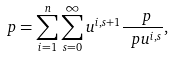<formula> <loc_0><loc_0><loc_500><loc_500>\ p = \sum _ { i = 1 } ^ { n } \sum _ { s = 0 } ^ { \infty } u ^ { i , s + 1 } \frac { \ p } { \ p u ^ { i , s } } ,</formula> 